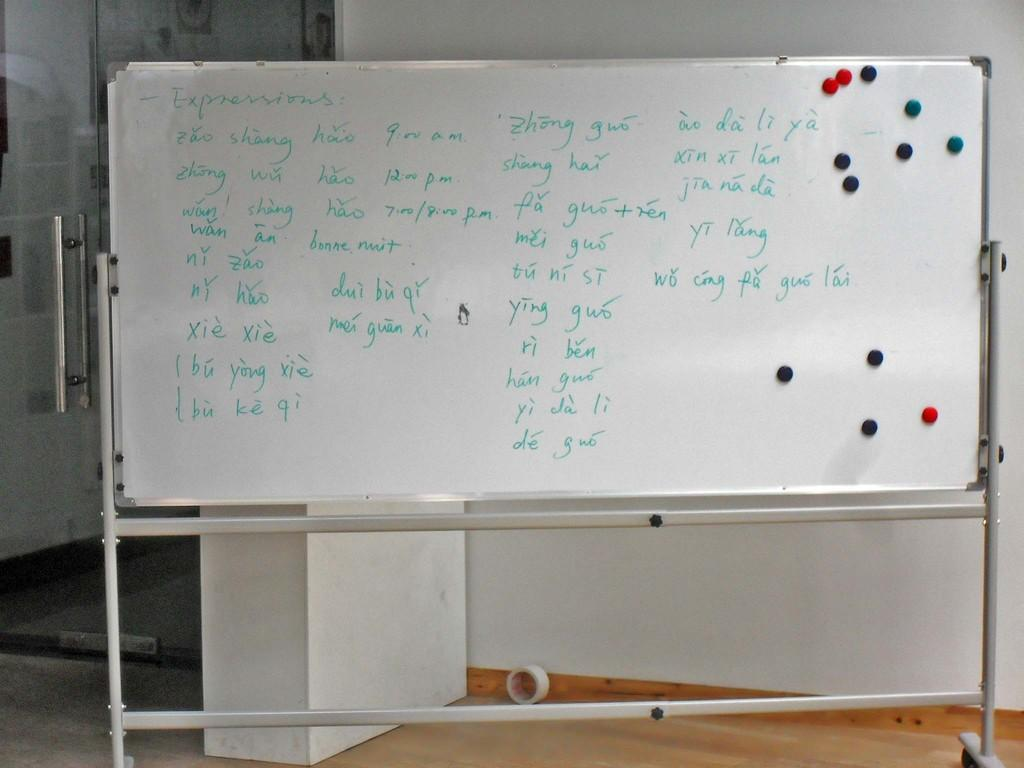<image>
Provide a brief description of the given image. A white board with various expressions in a foreign language, and times ranging from 9 am to 8 pm written on it. 